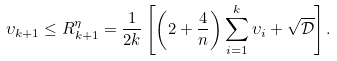<formula> <loc_0><loc_0><loc_500><loc_500>\upsilon _ { k + 1 } \leq R _ { k + 1 } ^ { \eta } = \frac { 1 } { 2 k } \left [ \left ( 2 + \frac { 4 } { n } \right ) \sum _ { i = 1 } ^ { k } \upsilon _ { i } + \sqrt { \mathcal { D } } \right ] .</formula> 